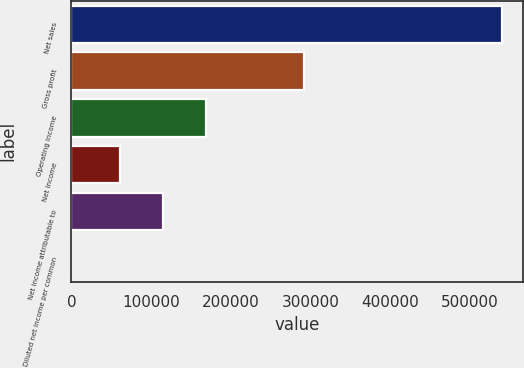Convert chart to OTSL. <chart><loc_0><loc_0><loc_500><loc_500><bar_chart><fcel>Net sales<fcel>Gross profit<fcel>Operating income<fcel>Net income<fcel>Net income attributable to<fcel>Diluted net income per common<nl><fcel>540344<fcel>292718<fcel>169280<fcel>61211<fcel>115245<fcel>0.28<nl></chart> 